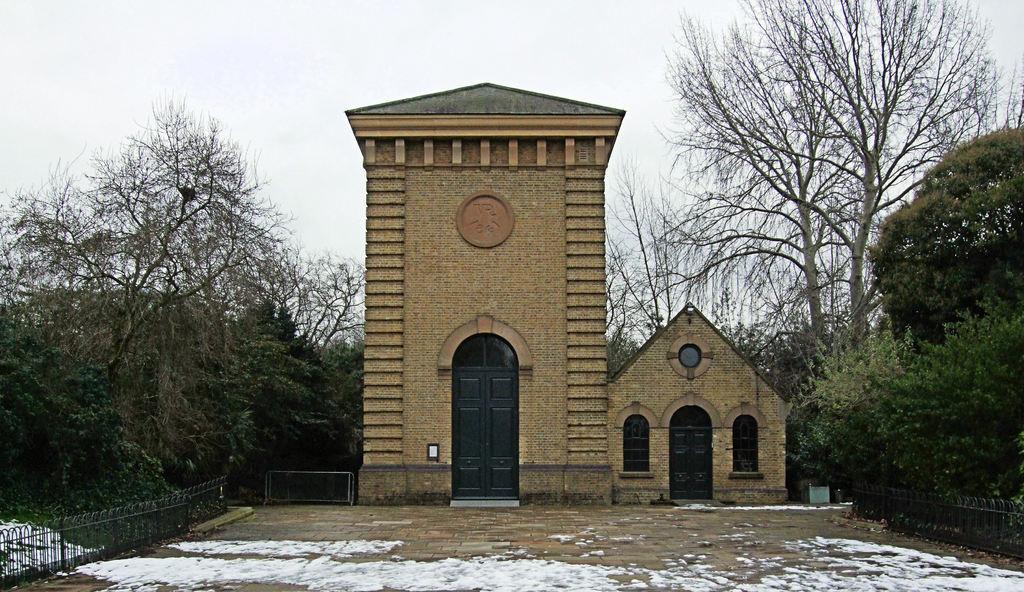Can you describe this image briefly? In this image, we can see buildings, fence and in the background, there are trees. 